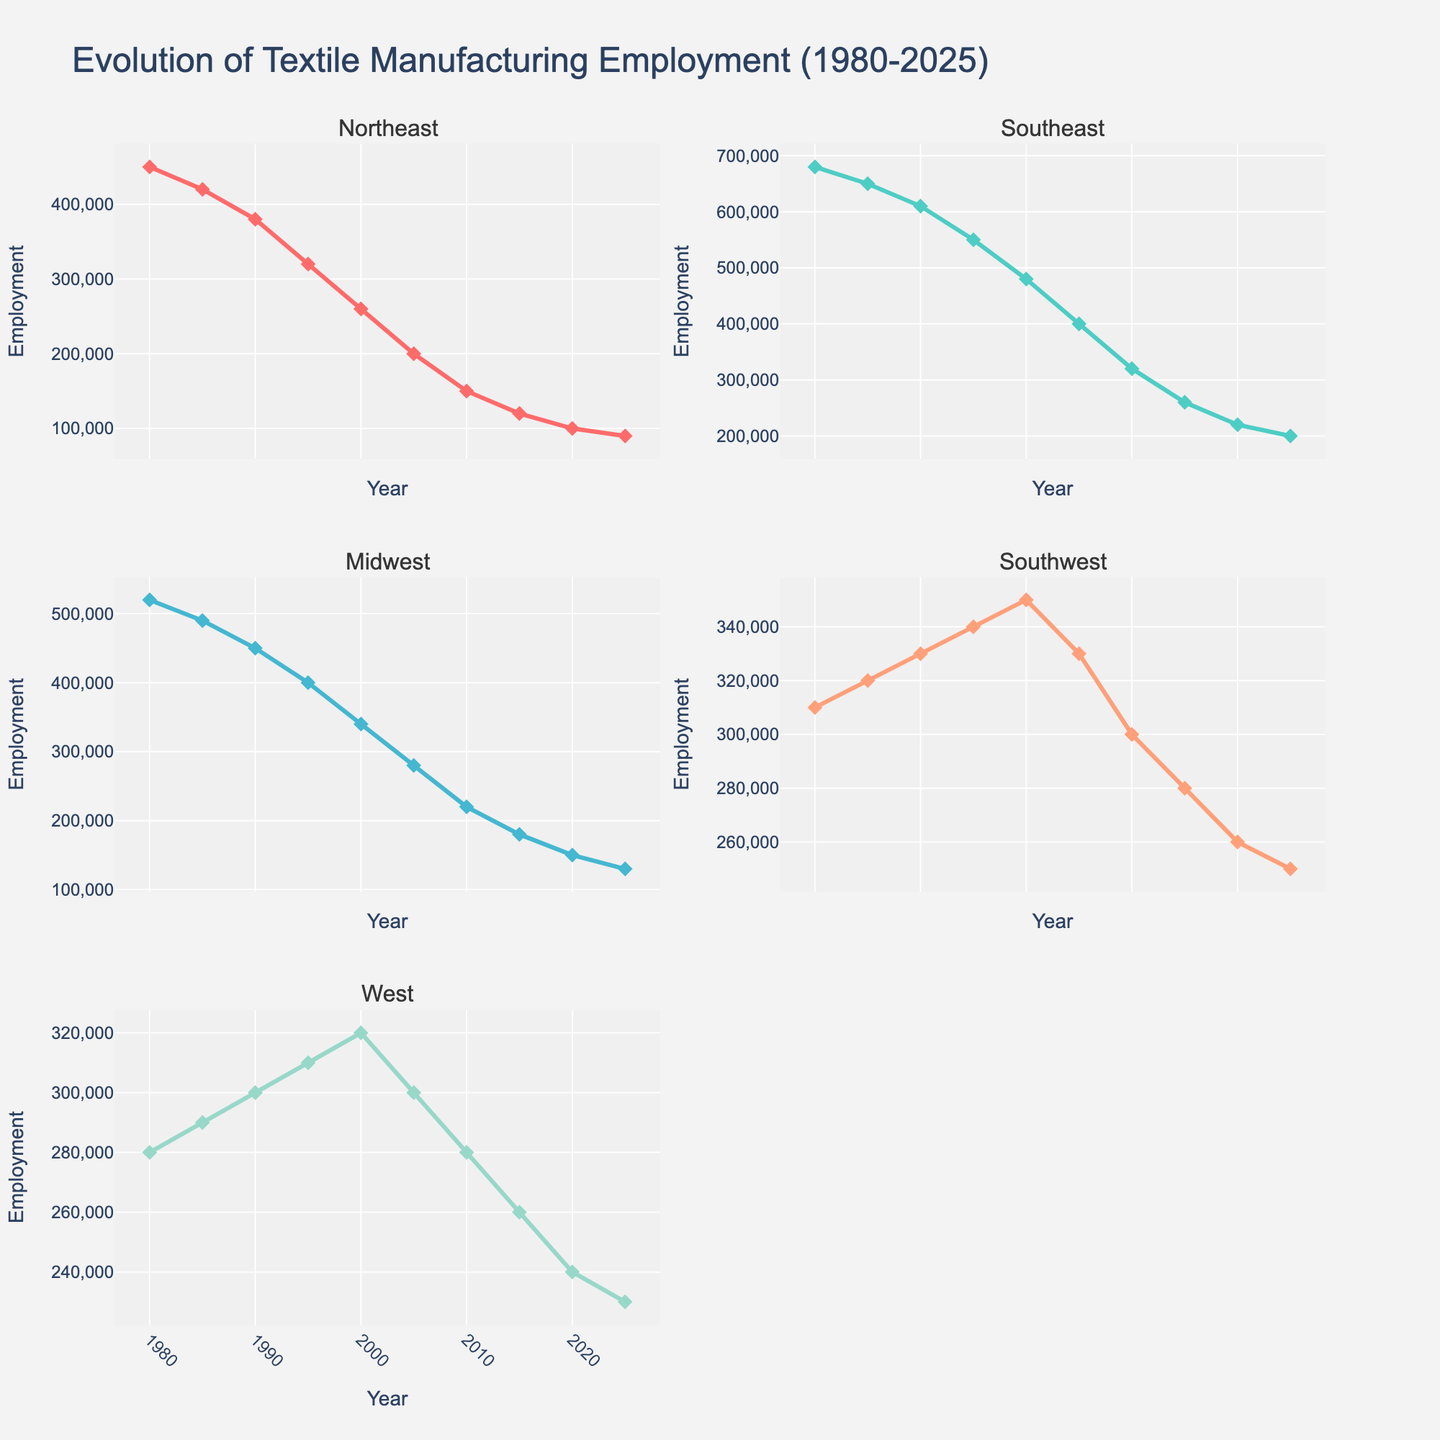What is the title of the figure? The title of the figure is prominently displayed at the top of the plot.
Answer: Evolution of Textile Manufacturing Employment (1980-2025) How many regions are displayed in the subplots? There is one subplot for each region. You can count the subplots by looking at the titles within the figure area.
Answer: Five Which region had the highest employment in 1980? To find the region with the highest employment, look at the y-values for the year 1980 across all subplots. The Southeast region has the highest employment.
Answer: Southeast What is the employment trend for the Midwest region between 1980 and 2025? Observe the Midwest subplot. The trend line shows a decrease in employment from 520,000 in 1980 to 130,000 in 2025.
Answer: Decreasing Between which consecutive years does the Southeast region see the largest drop in employment? Look at the Southeast subplot and identify the years where the decline in employment is the steepest. The largest drop is from 2000 to 2005.
Answer: 2000 to 2005 How does the employment in the Northeast region in 2025 compare to its employment in 1980? To compare the employment figures, find the y-values for 1980 and 2025 in the Northeast subplot. Employment dropped from 450,000 to 90,000.
Answer: Decrease by 360,000 What is the overall trend in textile employment in the West region from 1980 to 2025? Examine the line for the West region in its subplot. It shows a gradual decrease from 280,000 in 1980 to 230,000 in 2025.
Answer: Decreasing Which region had the smallest change in employment from 1980 to 2025? Find the difference in employment figures for each region between 1980 and 2025. The Southwest region shows a drop from 310,000 to 250,000, the smallest change.
Answer: Southwest 